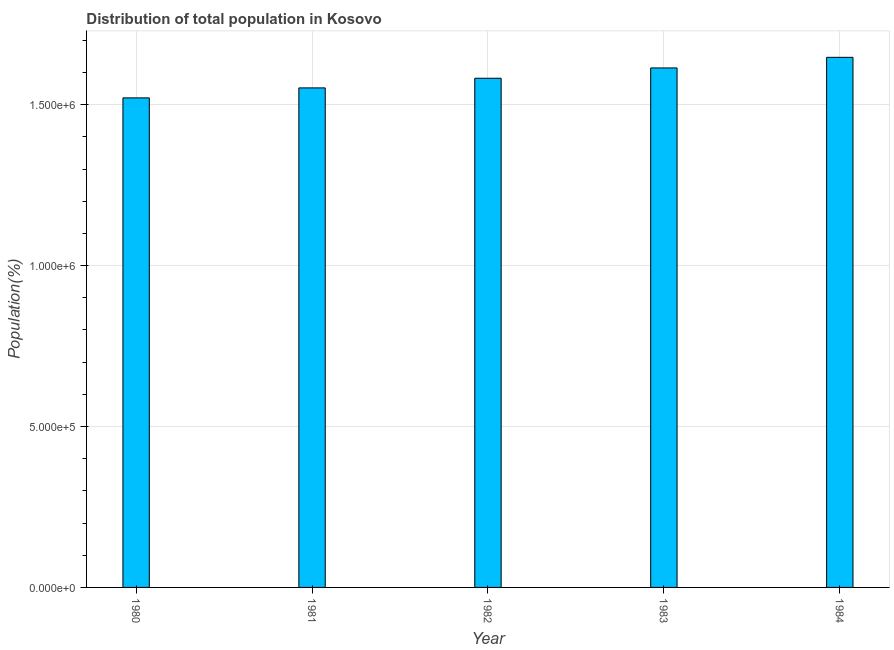Does the graph contain any zero values?
Provide a short and direct response. No. Does the graph contain grids?
Offer a very short reply. Yes. What is the title of the graph?
Your response must be concise. Distribution of total population in Kosovo . What is the label or title of the X-axis?
Provide a short and direct response. Year. What is the label or title of the Y-axis?
Offer a very short reply. Population(%). What is the population in 1981?
Keep it short and to the point. 1.55e+06. Across all years, what is the maximum population?
Provide a succinct answer. 1.65e+06. Across all years, what is the minimum population?
Your response must be concise. 1.52e+06. In which year was the population maximum?
Your answer should be compact. 1984. In which year was the population minimum?
Make the answer very short. 1980. What is the sum of the population?
Keep it short and to the point. 7.92e+06. What is the difference between the population in 1980 and 1981?
Your answer should be compact. -3.10e+04. What is the average population per year?
Offer a very short reply. 1.58e+06. What is the median population?
Make the answer very short. 1.58e+06. Do a majority of the years between 1983 and 1980 (inclusive) have population greater than 1200000 %?
Ensure brevity in your answer.  Yes. What is the ratio of the population in 1980 to that in 1983?
Offer a very short reply. 0.94. Is the population in 1980 less than that in 1984?
Make the answer very short. Yes. Is the difference between the population in 1981 and 1982 greater than the difference between any two years?
Your response must be concise. No. What is the difference between the highest and the second highest population?
Your answer should be compact. 3.30e+04. What is the difference between the highest and the lowest population?
Offer a very short reply. 1.26e+05. In how many years, is the population greater than the average population taken over all years?
Offer a very short reply. 2. How many years are there in the graph?
Provide a succinct answer. 5. What is the difference between two consecutive major ticks on the Y-axis?
Make the answer very short. 5.00e+05. What is the Population(%) of 1980?
Your answer should be very brief. 1.52e+06. What is the Population(%) in 1981?
Ensure brevity in your answer.  1.55e+06. What is the Population(%) in 1982?
Provide a short and direct response. 1.58e+06. What is the Population(%) of 1983?
Your response must be concise. 1.61e+06. What is the Population(%) of 1984?
Offer a very short reply. 1.65e+06. What is the difference between the Population(%) in 1980 and 1981?
Give a very brief answer. -3.10e+04. What is the difference between the Population(%) in 1980 and 1982?
Provide a short and direct response. -6.10e+04. What is the difference between the Population(%) in 1980 and 1983?
Your answer should be compact. -9.30e+04. What is the difference between the Population(%) in 1980 and 1984?
Your answer should be very brief. -1.26e+05. What is the difference between the Population(%) in 1981 and 1983?
Your answer should be compact. -6.20e+04. What is the difference between the Population(%) in 1981 and 1984?
Your answer should be compact. -9.50e+04. What is the difference between the Population(%) in 1982 and 1983?
Keep it short and to the point. -3.20e+04. What is the difference between the Population(%) in 1982 and 1984?
Make the answer very short. -6.50e+04. What is the difference between the Population(%) in 1983 and 1984?
Provide a short and direct response. -3.30e+04. What is the ratio of the Population(%) in 1980 to that in 1981?
Your answer should be compact. 0.98. What is the ratio of the Population(%) in 1980 to that in 1982?
Your response must be concise. 0.96. What is the ratio of the Population(%) in 1980 to that in 1983?
Make the answer very short. 0.94. What is the ratio of the Population(%) in 1980 to that in 1984?
Provide a succinct answer. 0.92. What is the ratio of the Population(%) in 1981 to that in 1982?
Make the answer very short. 0.98. What is the ratio of the Population(%) in 1981 to that in 1984?
Ensure brevity in your answer.  0.94. What is the ratio of the Population(%) in 1982 to that in 1983?
Provide a succinct answer. 0.98. 